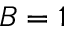Convert formula to latex. <formula><loc_0><loc_0><loc_500><loc_500>B = 1</formula> 